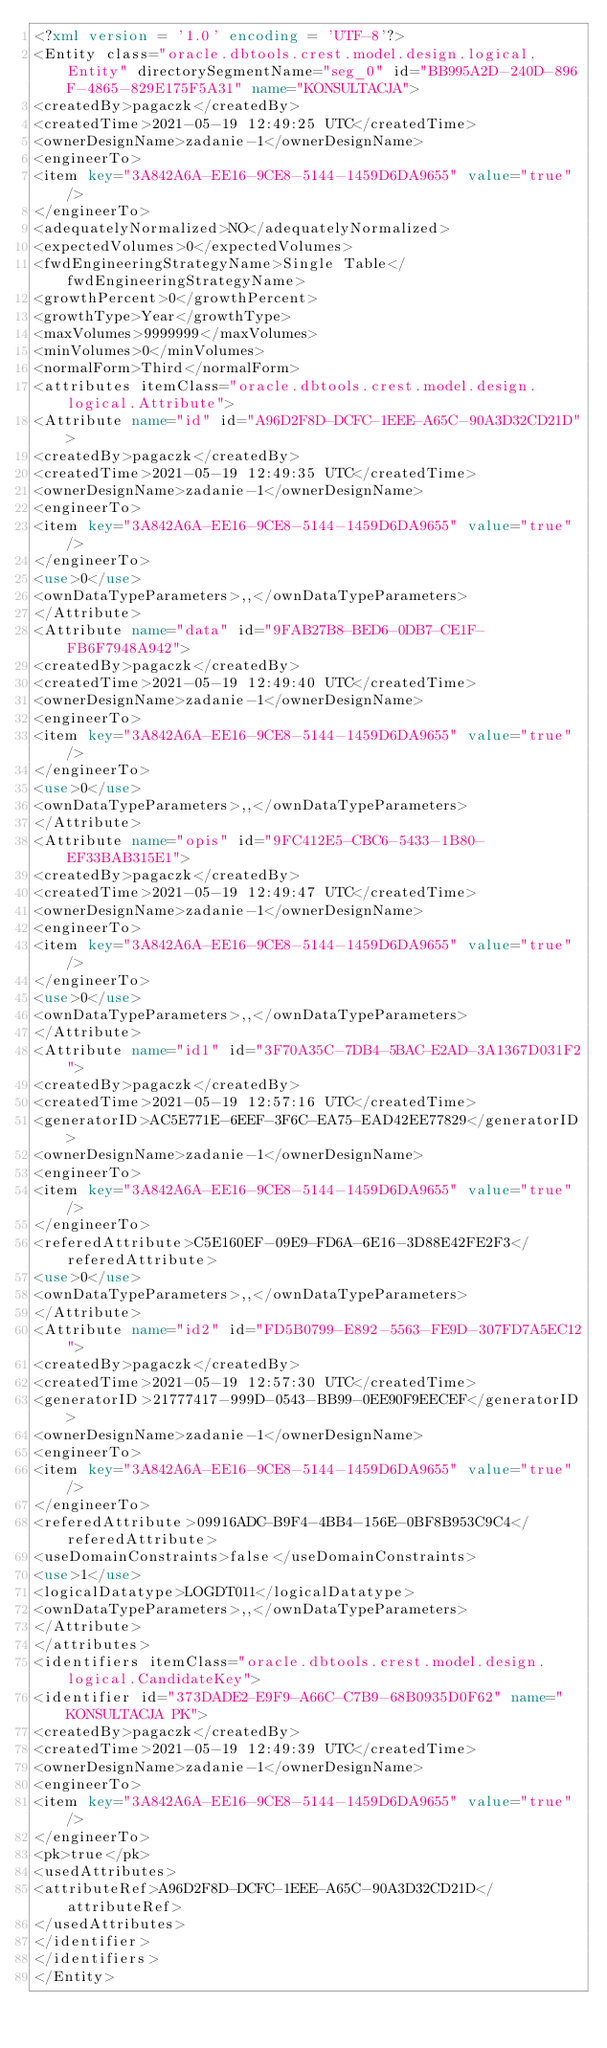Convert code to text. <code><loc_0><loc_0><loc_500><loc_500><_XML_><?xml version = '1.0' encoding = 'UTF-8'?>
<Entity class="oracle.dbtools.crest.model.design.logical.Entity" directorySegmentName="seg_0" id="BB995A2D-240D-896F-4865-829E175F5A31" name="KONSULTACJA">
<createdBy>pagaczk</createdBy>
<createdTime>2021-05-19 12:49:25 UTC</createdTime>
<ownerDesignName>zadanie-1</ownerDesignName>
<engineerTo>
<item key="3A842A6A-EE16-9CE8-5144-1459D6DA9655" value="true"/>
</engineerTo>
<adequatelyNormalized>NO</adequatelyNormalized>
<expectedVolumes>0</expectedVolumes>
<fwdEngineeringStrategyName>Single Table</fwdEngineeringStrategyName>
<growthPercent>0</growthPercent>
<growthType>Year</growthType>
<maxVolumes>9999999</maxVolumes>
<minVolumes>0</minVolumes>
<normalForm>Third</normalForm>
<attributes itemClass="oracle.dbtools.crest.model.design.logical.Attribute">
<Attribute name="id" id="A96D2F8D-DCFC-1EEE-A65C-90A3D32CD21D">
<createdBy>pagaczk</createdBy>
<createdTime>2021-05-19 12:49:35 UTC</createdTime>
<ownerDesignName>zadanie-1</ownerDesignName>
<engineerTo>
<item key="3A842A6A-EE16-9CE8-5144-1459D6DA9655" value="true"/>
</engineerTo>
<use>0</use>
<ownDataTypeParameters>,,</ownDataTypeParameters>
</Attribute>
<Attribute name="data" id="9FAB27B8-BED6-0DB7-CE1F-FB6F7948A942">
<createdBy>pagaczk</createdBy>
<createdTime>2021-05-19 12:49:40 UTC</createdTime>
<ownerDesignName>zadanie-1</ownerDesignName>
<engineerTo>
<item key="3A842A6A-EE16-9CE8-5144-1459D6DA9655" value="true"/>
</engineerTo>
<use>0</use>
<ownDataTypeParameters>,,</ownDataTypeParameters>
</Attribute>
<Attribute name="opis" id="9FC412E5-CBC6-5433-1B80-EF33BAB315E1">
<createdBy>pagaczk</createdBy>
<createdTime>2021-05-19 12:49:47 UTC</createdTime>
<ownerDesignName>zadanie-1</ownerDesignName>
<engineerTo>
<item key="3A842A6A-EE16-9CE8-5144-1459D6DA9655" value="true"/>
</engineerTo>
<use>0</use>
<ownDataTypeParameters>,,</ownDataTypeParameters>
</Attribute>
<Attribute name="id1" id="3F70A35C-7DB4-5BAC-E2AD-3A1367D031F2">
<createdBy>pagaczk</createdBy>
<createdTime>2021-05-19 12:57:16 UTC</createdTime>
<generatorID>AC5E771E-6EEF-3F6C-EA75-EAD42EE77829</generatorID>
<ownerDesignName>zadanie-1</ownerDesignName>
<engineerTo>
<item key="3A842A6A-EE16-9CE8-5144-1459D6DA9655" value="true"/>
</engineerTo>
<referedAttribute>C5E160EF-09E9-FD6A-6E16-3D88E42FE2F3</referedAttribute>
<use>0</use>
<ownDataTypeParameters>,,</ownDataTypeParameters>
</Attribute>
<Attribute name="id2" id="FD5B0799-E892-5563-FE9D-307FD7A5EC12">
<createdBy>pagaczk</createdBy>
<createdTime>2021-05-19 12:57:30 UTC</createdTime>
<generatorID>21777417-999D-0543-BB99-0EE90F9EECEF</generatorID>
<ownerDesignName>zadanie-1</ownerDesignName>
<engineerTo>
<item key="3A842A6A-EE16-9CE8-5144-1459D6DA9655" value="true"/>
</engineerTo>
<referedAttribute>09916ADC-B9F4-4BB4-156E-0BF8B953C9C4</referedAttribute>
<useDomainConstraints>false</useDomainConstraints>
<use>1</use>
<logicalDatatype>LOGDT011</logicalDatatype>
<ownDataTypeParameters>,,</ownDataTypeParameters>
</Attribute>
</attributes>
<identifiers itemClass="oracle.dbtools.crest.model.design.logical.CandidateKey">
<identifier id="373DADE2-E9F9-A66C-C7B9-68B0935D0F62" name="KONSULTACJA PK">
<createdBy>pagaczk</createdBy>
<createdTime>2021-05-19 12:49:39 UTC</createdTime>
<ownerDesignName>zadanie-1</ownerDesignName>
<engineerTo>
<item key="3A842A6A-EE16-9CE8-5144-1459D6DA9655" value="true"/>
</engineerTo>
<pk>true</pk>
<usedAttributes>
<attributeRef>A96D2F8D-DCFC-1EEE-A65C-90A3D32CD21D</attributeRef>
</usedAttributes>
</identifier>
</identifiers>
</Entity></code> 